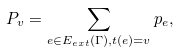Convert formula to latex. <formula><loc_0><loc_0><loc_500><loc_500>P _ { v } = \sum _ { e \in E _ { e x t } ( \Gamma ) , t ( e ) = v } p _ { e } ,</formula> 